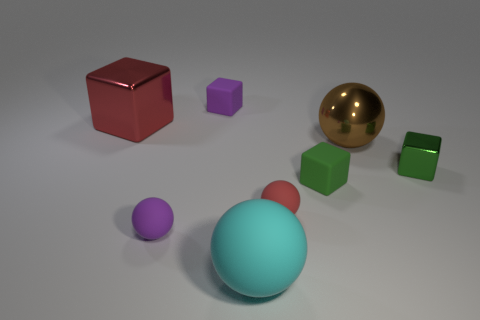Do the brown metal sphere and the purple block have the same size? No, they do not have the same size. The brown metal sphere appears larger than the purple block when comparing their sizes visually in the image. 